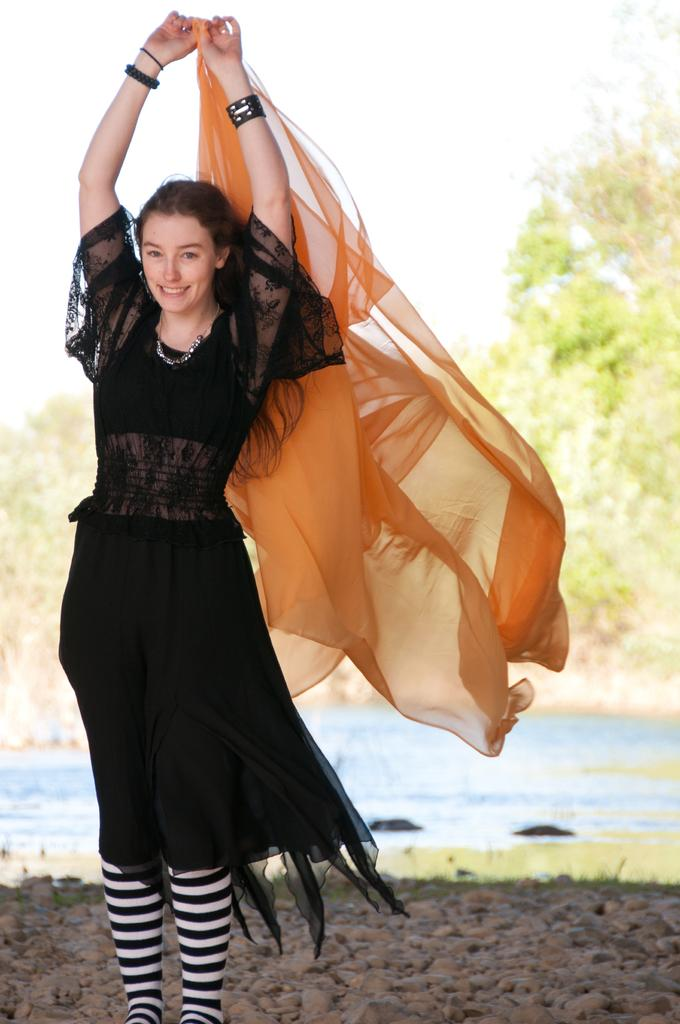What is the woman doing in the image? The woman is standing and smiling in the image. What is the woman holding in the image? The woman is holding some cloth in the image. What can be seen in the background of the image? There are trees in the background of the image. What type of surface is visible at the bottom of the image? There are stones at the bottom of the image. What body of water is visible in the image? There is a lake visible in the image. What type of food is the woman eating in the image? There is no food visible in the image, and the woman is not shown eating anything. Can you see an airplane flying over the lake in the image? There is no airplane present in the image; it only features a woman, some cloth, trees, stones, and a lake. 